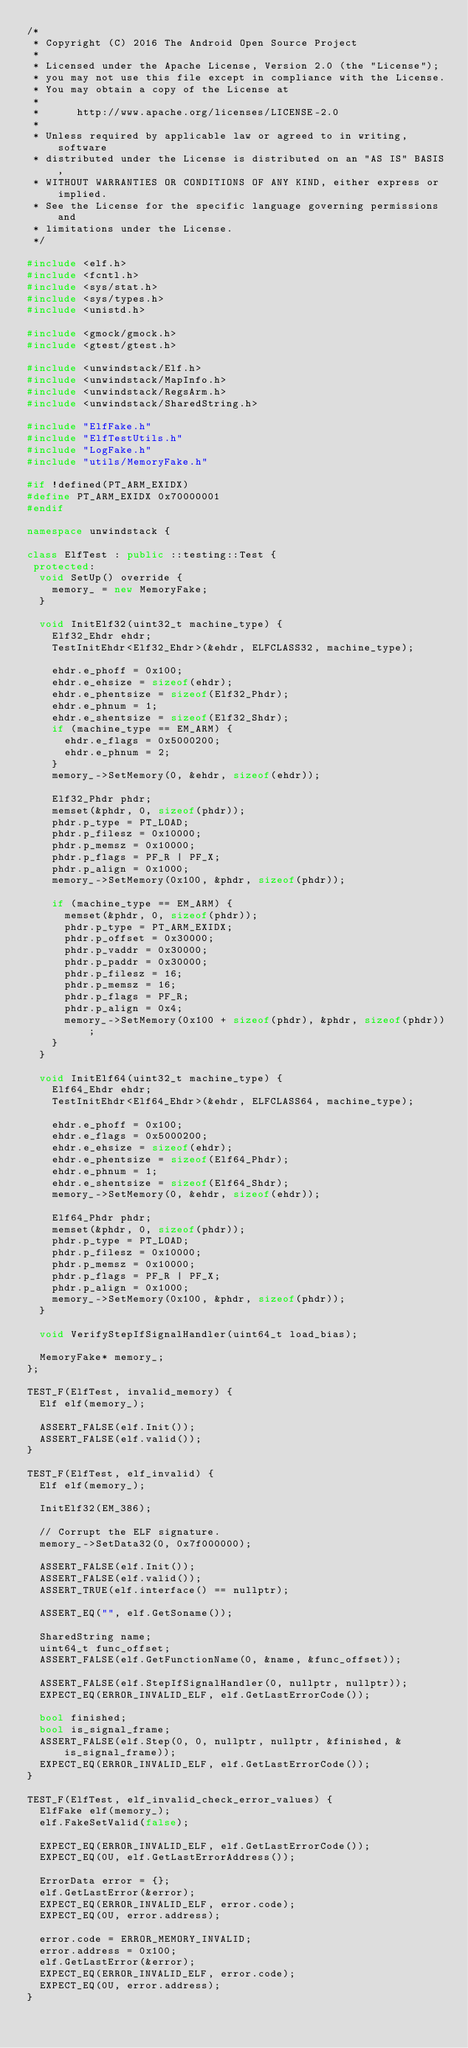Convert code to text. <code><loc_0><loc_0><loc_500><loc_500><_C++_>/*
 * Copyright (C) 2016 The Android Open Source Project
 *
 * Licensed under the Apache License, Version 2.0 (the "License");
 * you may not use this file except in compliance with the License.
 * You may obtain a copy of the License at
 *
 *      http://www.apache.org/licenses/LICENSE-2.0
 *
 * Unless required by applicable law or agreed to in writing, software
 * distributed under the License is distributed on an "AS IS" BASIS,
 * WITHOUT WARRANTIES OR CONDITIONS OF ANY KIND, either express or implied.
 * See the License for the specific language governing permissions and
 * limitations under the License.
 */

#include <elf.h>
#include <fcntl.h>
#include <sys/stat.h>
#include <sys/types.h>
#include <unistd.h>

#include <gmock/gmock.h>
#include <gtest/gtest.h>

#include <unwindstack/Elf.h>
#include <unwindstack/MapInfo.h>
#include <unwindstack/RegsArm.h>
#include <unwindstack/SharedString.h>

#include "ElfFake.h"
#include "ElfTestUtils.h"
#include "LogFake.h"
#include "utils/MemoryFake.h"

#if !defined(PT_ARM_EXIDX)
#define PT_ARM_EXIDX 0x70000001
#endif

namespace unwindstack {

class ElfTest : public ::testing::Test {
 protected:
  void SetUp() override {
    memory_ = new MemoryFake;
  }

  void InitElf32(uint32_t machine_type) {
    Elf32_Ehdr ehdr;
    TestInitEhdr<Elf32_Ehdr>(&ehdr, ELFCLASS32, machine_type);

    ehdr.e_phoff = 0x100;
    ehdr.e_ehsize = sizeof(ehdr);
    ehdr.e_phentsize = sizeof(Elf32_Phdr);
    ehdr.e_phnum = 1;
    ehdr.e_shentsize = sizeof(Elf32_Shdr);
    if (machine_type == EM_ARM) {
      ehdr.e_flags = 0x5000200;
      ehdr.e_phnum = 2;
    }
    memory_->SetMemory(0, &ehdr, sizeof(ehdr));

    Elf32_Phdr phdr;
    memset(&phdr, 0, sizeof(phdr));
    phdr.p_type = PT_LOAD;
    phdr.p_filesz = 0x10000;
    phdr.p_memsz = 0x10000;
    phdr.p_flags = PF_R | PF_X;
    phdr.p_align = 0x1000;
    memory_->SetMemory(0x100, &phdr, sizeof(phdr));

    if (machine_type == EM_ARM) {
      memset(&phdr, 0, sizeof(phdr));
      phdr.p_type = PT_ARM_EXIDX;
      phdr.p_offset = 0x30000;
      phdr.p_vaddr = 0x30000;
      phdr.p_paddr = 0x30000;
      phdr.p_filesz = 16;
      phdr.p_memsz = 16;
      phdr.p_flags = PF_R;
      phdr.p_align = 0x4;
      memory_->SetMemory(0x100 + sizeof(phdr), &phdr, sizeof(phdr));
    }
  }

  void InitElf64(uint32_t machine_type) {
    Elf64_Ehdr ehdr;
    TestInitEhdr<Elf64_Ehdr>(&ehdr, ELFCLASS64, machine_type);

    ehdr.e_phoff = 0x100;
    ehdr.e_flags = 0x5000200;
    ehdr.e_ehsize = sizeof(ehdr);
    ehdr.e_phentsize = sizeof(Elf64_Phdr);
    ehdr.e_phnum = 1;
    ehdr.e_shentsize = sizeof(Elf64_Shdr);
    memory_->SetMemory(0, &ehdr, sizeof(ehdr));

    Elf64_Phdr phdr;
    memset(&phdr, 0, sizeof(phdr));
    phdr.p_type = PT_LOAD;
    phdr.p_filesz = 0x10000;
    phdr.p_memsz = 0x10000;
    phdr.p_flags = PF_R | PF_X;
    phdr.p_align = 0x1000;
    memory_->SetMemory(0x100, &phdr, sizeof(phdr));
  }

  void VerifyStepIfSignalHandler(uint64_t load_bias);

  MemoryFake* memory_;
};

TEST_F(ElfTest, invalid_memory) {
  Elf elf(memory_);

  ASSERT_FALSE(elf.Init());
  ASSERT_FALSE(elf.valid());
}

TEST_F(ElfTest, elf_invalid) {
  Elf elf(memory_);

  InitElf32(EM_386);

  // Corrupt the ELF signature.
  memory_->SetData32(0, 0x7f000000);

  ASSERT_FALSE(elf.Init());
  ASSERT_FALSE(elf.valid());
  ASSERT_TRUE(elf.interface() == nullptr);

  ASSERT_EQ("", elf.GetSoname());

  SharedString name;
  uint64_t func_offset;
  ASSERT_FALSE(elf.GetFunctionName(0, &name, &func_offset));

  ASSERT_FALSE(elf.StepIfSignalHandler(0, nullptr, nullptr));
  EXPECT_EQ(ERROR_INVALID_ELF, elf.GetLastErrorCode());

  bool finished;
  bool is_signal_frame;
  ASSERT_FALSE(elf.Step(0, 0, nullptr, nullptr, &finished, &is_signal_frame));
  EXPECT_EQ(ERROR_INVALID_ELF, elf.GetLastErrorCode());
}

TEST_F(ElfTest, elf_invalid_check_error_values) {
  ElfFake elf(memory_);
  elf.FakeSetValid(false);

  EXPECT_EQ(ERROR_INVALID_ELF, elf.GetLastErrorCode());
  EXPECT_EQ(0U, elf.GetLastErrorAddress());

  ErrorData error = {};
  elf.GetLastError(&error);
  EXPECT_EQ(ERROR_INVALID_ELF, error.code);
  EXPECT_EQ(0U, error.address);

  error.code = ERROR_MEMORY_INVALID;
  error.address = 0x100;
  elf.GetLastError(&error);
  EXPECT_EQ(ERROR_INVALID_ELF, error.code);
  EXPECT_EQ(0U, error.address);
}
</code> 